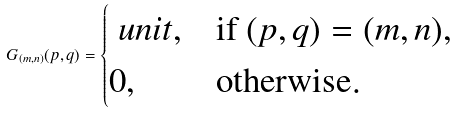<formula> <loc_0><loc_0><loc_500><loc_500>G _ { ( m , n ) } ( p , q ) = \begin{cases} \ u n i t , & \text {if $(p,q) = (m,n)$} , \\ 0 , & \text {otherwise} . \end{cases}</formula> 